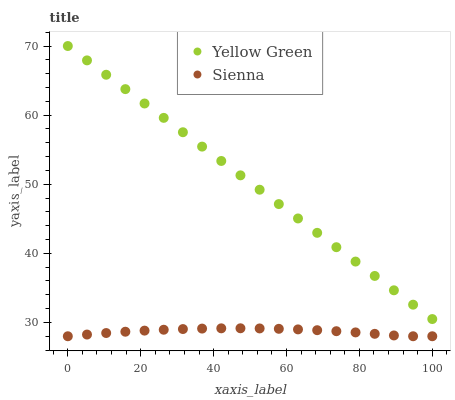Does Sienna have the minimum area under the curve?
Answer yes or no. Yes. Does Yellow Green have the maximum area under the curve?
Answer yes or no. Yes. Does Yellow Green have the minimum area under the curve?
Answer yes or no. No. Is Yellow Green the smoothest?
Answer yes or no. Yes. Is Sienna the roughest?
Answer yes or no. Yes. Is Yellow Green the roughest?
Answer yes or no. No. Does Sienna have the lowest value?
Answer yes or no. Yes. Does Yellow Green have the lowest value?
Answer yes or no. No. Does Yellow Green have the highest value?
Answer yes or no. Yes. Is Sienna less than Yellow Green?
Answer yes or no. Yes. Is Yellow Green greater than Sienna?
Answer yes or no. Yes. Does Sienna intersect Yellow Green?
Answer yes or no. No. 